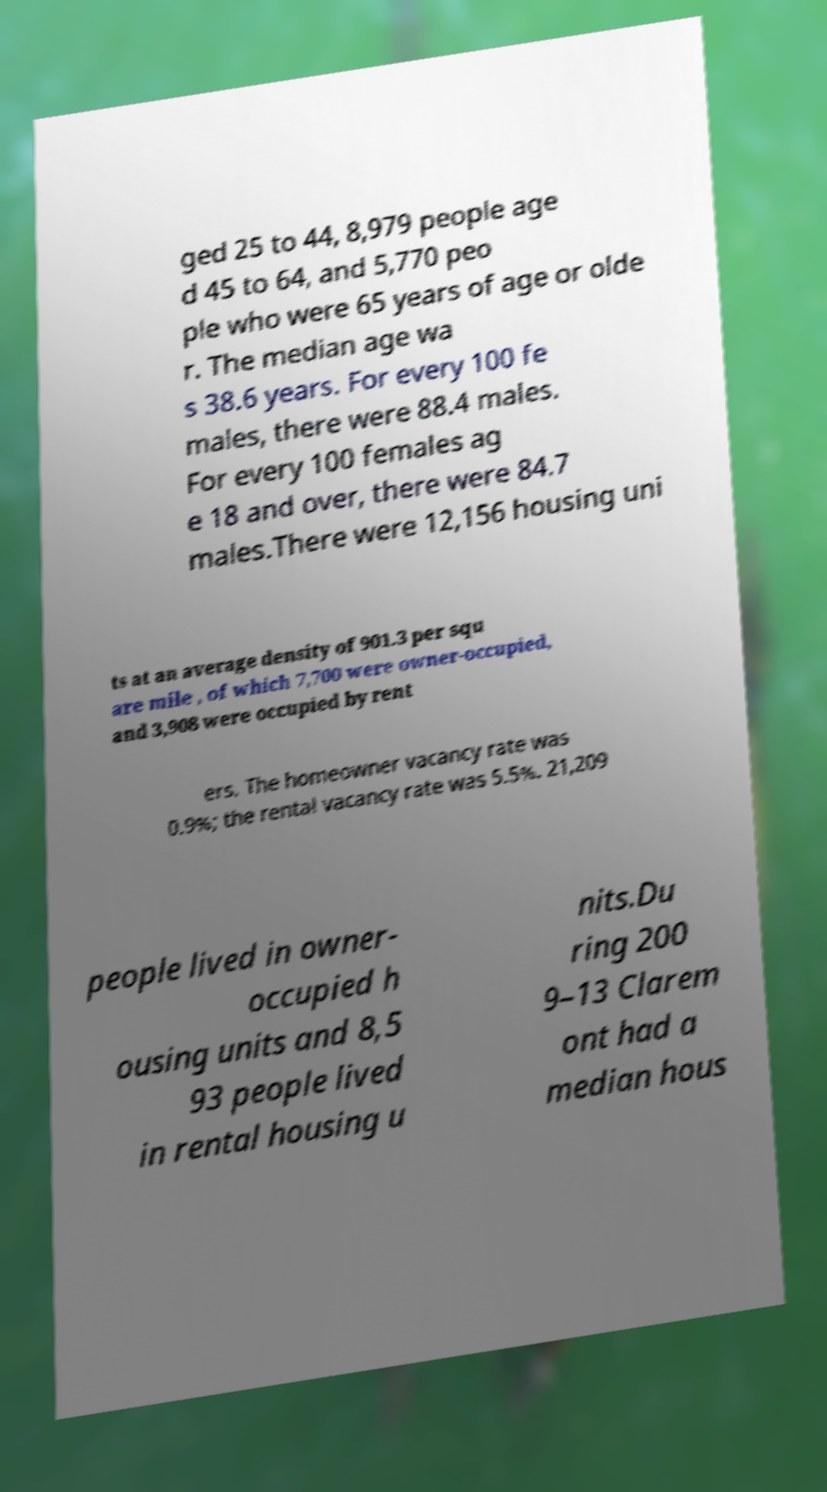Could you extract and type out the text from this image? ged 25 to 44, 8,979 people age d 45 to 64, and 5,770 peo ple who were 65 years of age or olde r. The median age wa s 38.6 years. For every 100 fe males, there were 88.4 males. For every 100 females ag e 18 and over, there were 84.7 males.There were 12,156 housing uni ts at an average density of 901.3 per squ are mile , of which 7,700 were owner-occupied, and 3,908 were occupied by rent ers. The homeowner vacancy rate was 0.9%; the rental vacancy rate was 5.5%. 21,209 people lived in owner- occupied h ousing units and 8,5 93 people lived in rental housing u nits.Du ring 200 9–13 Clarem ont had a median hous 